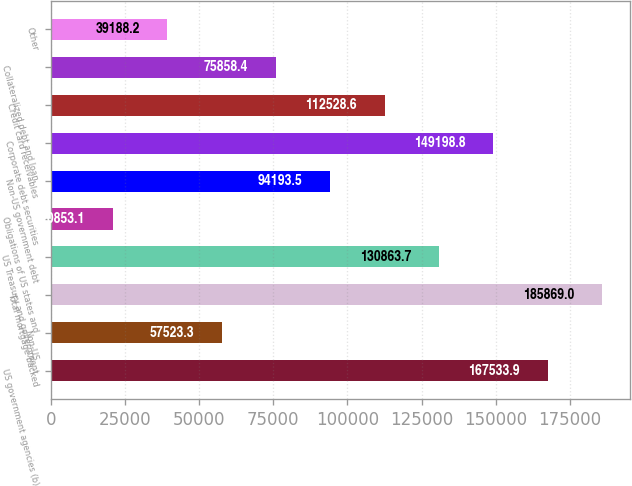Convert chart to OTSL. <chart><loc_0><loc_0><loc_500><loc_500><bar_chart><fcel>US government agencies (b)<fcel>Non-US<fcel>Total mortgage-backed<fcel>US Treasury and government<fcel>Obligations of US states and<fcel>Non-US government debt<fcel>Corporate debt securities<fcel>Credit card receivables<fcel>Collateralized debt and loan<fcel>Other<nl><fcel>167534<fcel>57523.3<fcel>185869<fcel>130864<fcel>20853.1<fcel>94193.5<fcel>149199<fcel>112529<fcel>75858.4<fcel>39188.2<nl></chart> 